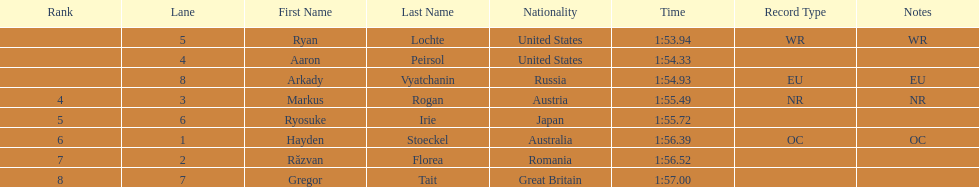How many swimmers were from the us? 2. 